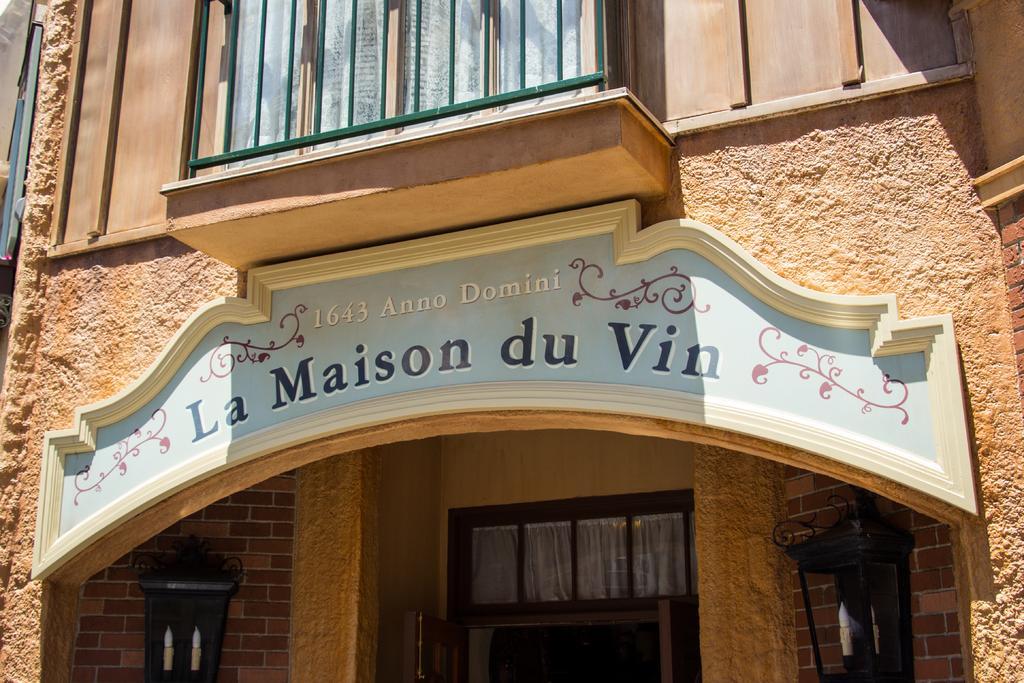Please provide a concise description of this image. In this picture we can see the wall, windows. Through glass we can see curtains. We can see lights on the wall. At the top we can see there is something written, wooden wall and a grill. This picture is taken during a day and it seems like a sunny day. 